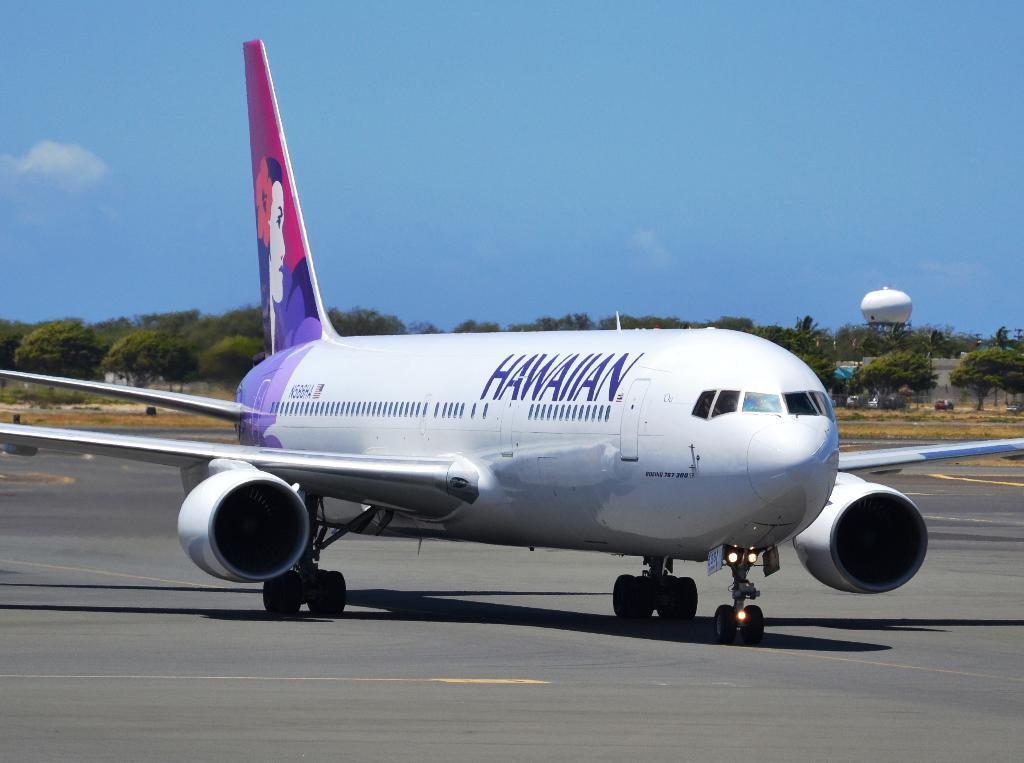<image>
Present a compact description of the photo's key features. A white passenger jet that says Hawaiian is taxiing on the runway. 